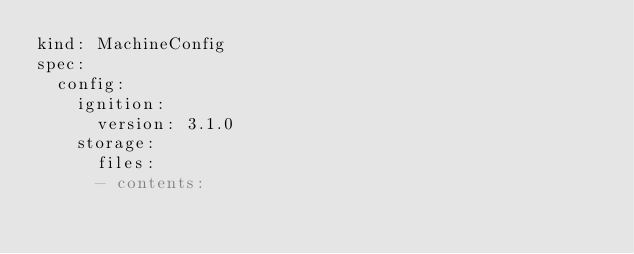Convert code to text. <code><loc_0><loc_0><loc_500><loc_500><_YAML_>kind: MachineConfig
spec:
  config:
    ignition:
      version: 3.1.0
    storage:
      files:
      - contents:</code> 